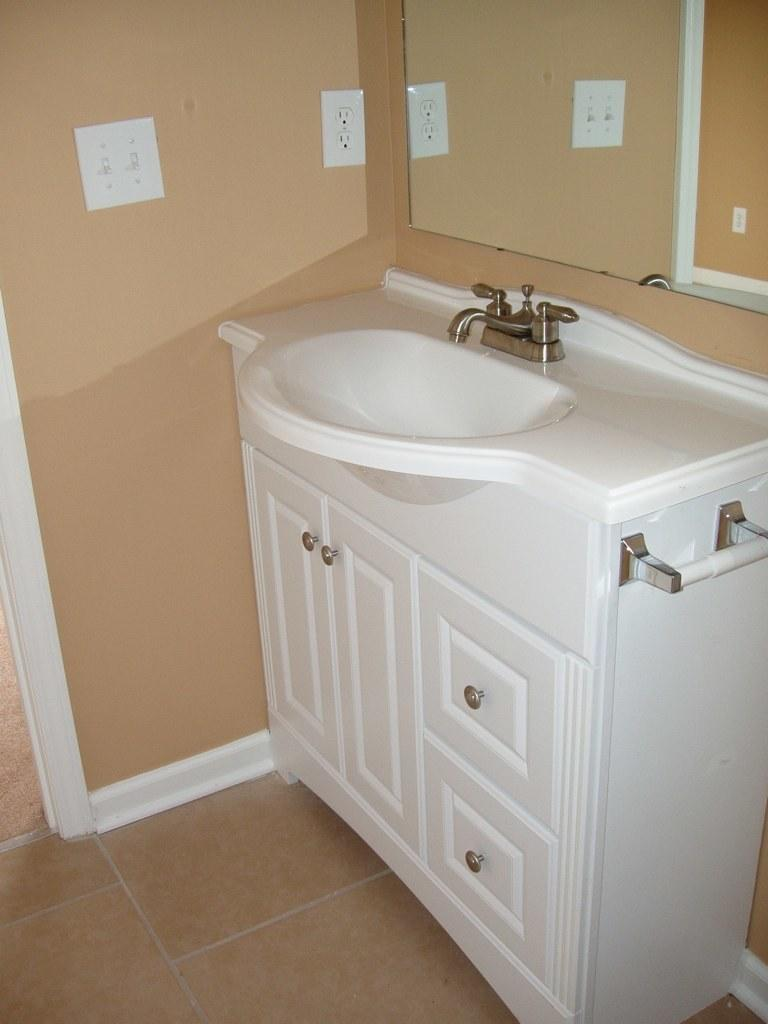What type of fixture is present in the image? There is a white color sink in the image. What is attached to the sink? There is a tap in the image. What is used for reflection in the image? There is a mirror in the image. What color is the wall on which the mirror is mounted? The mirror is mounted on a brown color wall. How many cherries are on the feet of the person in the image? There is no person or cherries present in the image. 